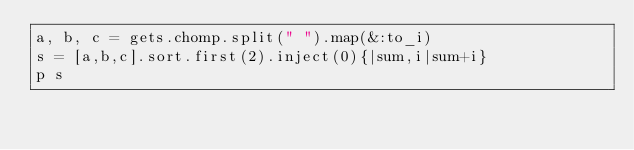Convert code to text. <code><loc_0><loc_0><loc_500><loc_500><_Ruby_>a, b, c = gets.chomp.split(" ").map(&:to_i)
s = [a,b,c].sort.first(2).inject(0){|sum,i|sum+i}
p s</code> 